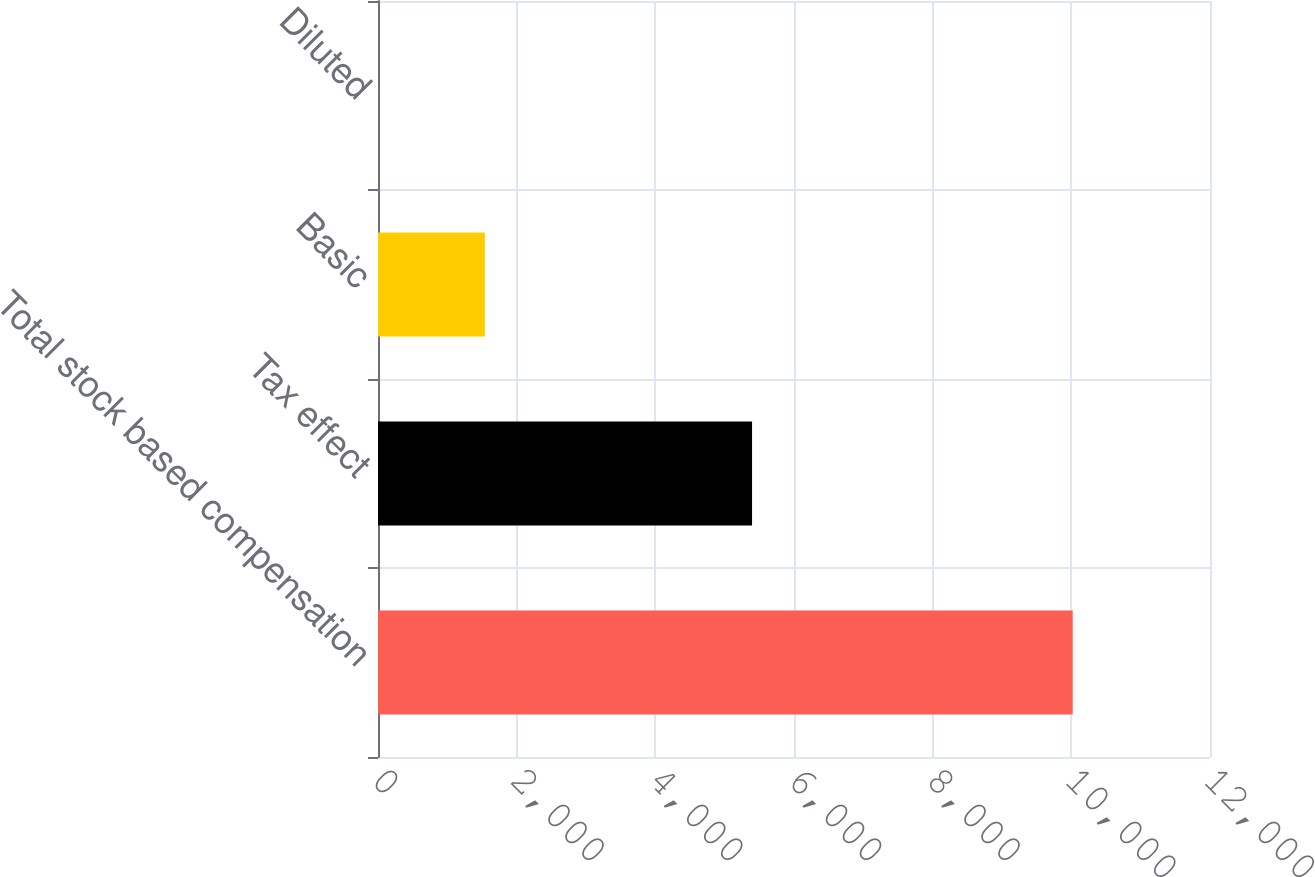<chart> <loc_0><loc_0><loc_500><loc_500><bar_chart><fcel>Total stock based compensation<fcel>Tax effect<fcel>Basic<fcel>Diluted<nl><fcel>10020<fcel>5395<fcel>1541.6<fcel>0.11<nl></chart> 